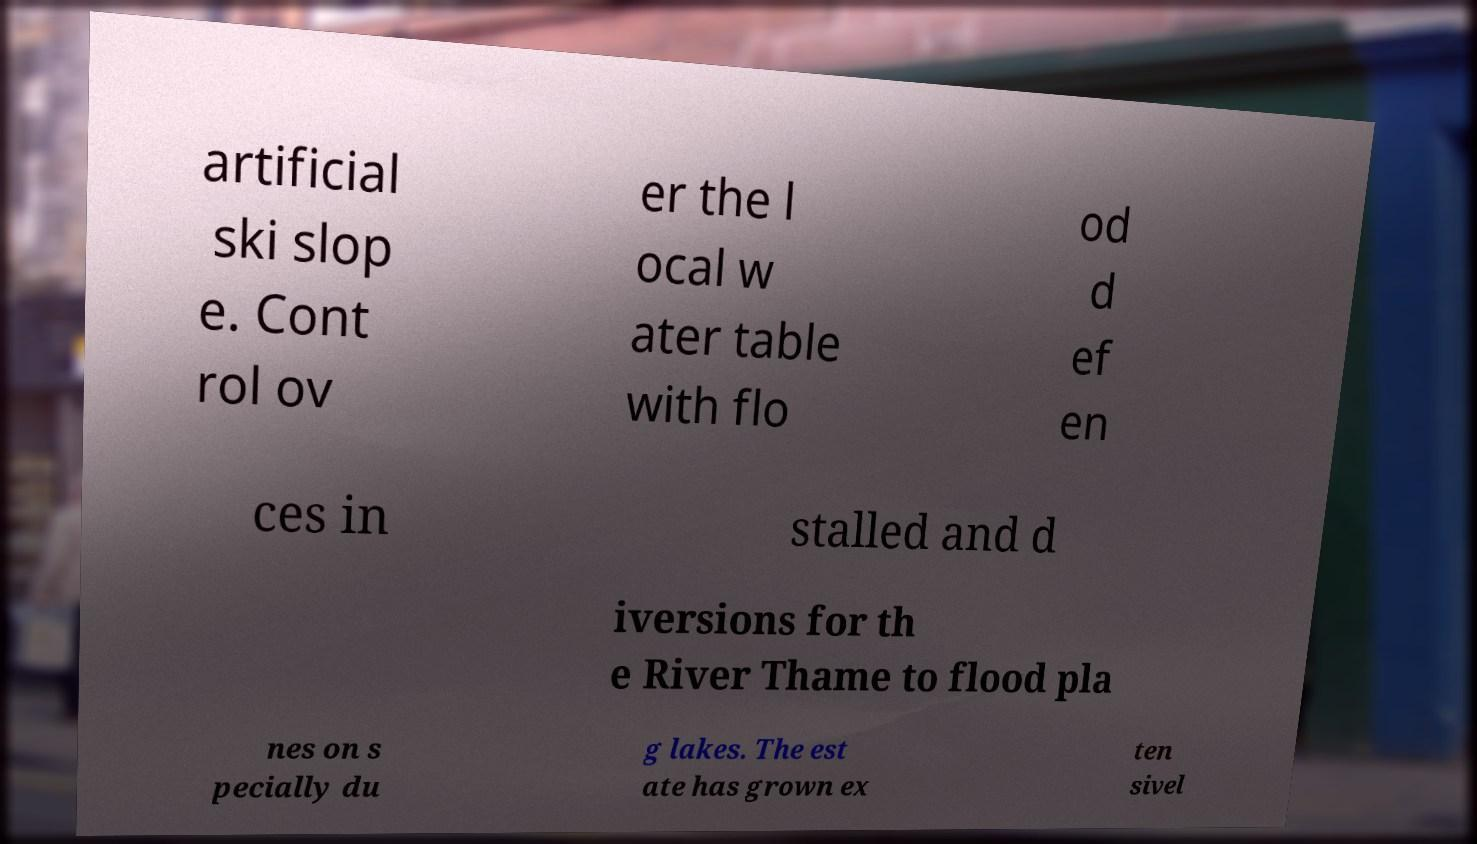There's text embedded in this image that I need extracted. Can you transcribe it verbatim? artificial ski slop e. Cont rol ov er the l ocal w ater table with flo od d ef en ces in stalled and d iversions for th e River Thame to flood pla nes on s pecially du g lakes. The est ate has grown ex ten sivel 